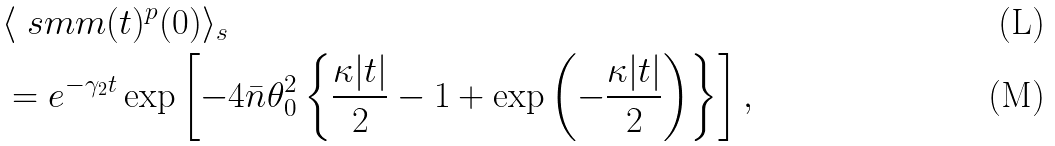<formula> <loc_0><loc_0><loc_500><loc_500>& \langle \ s m m ( t ) ^ { p } ( 0 ) \rangle _ { s } \\ & = e ^ { - \gamma _ { 2 } t } \exp \left [ - 4 \bar { n } \theta _ { 0 } ^ { 2 } \left \{ \frac { \kappa | t | } { 2 } - 1 + \exp \left ( - \frac { \kappa | t | } { 2 } \right ) \right \} \right ] ,</formula> 